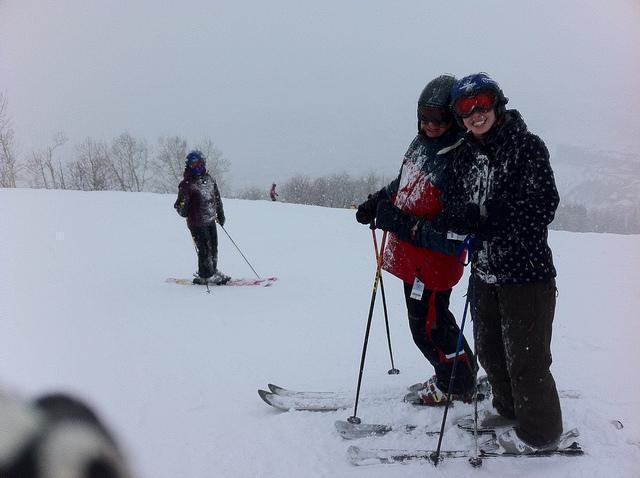To which elevation will the persons pictured here likely go to on their skis?
Answer the question by selecting the correct answer among the 4 following choices and explain your choice with a short sentence. The answer should be formatted with the following format: `Answer: choice
Rationale: rationale.`
Options: Sea level, higher, same, lower. Answer: lower.
Rationale: People are on skis at at the top of a mountain. 